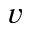Convert formula to latex. <formula><loc_0><loc_0><loc_500><loc_500>v</formula> 